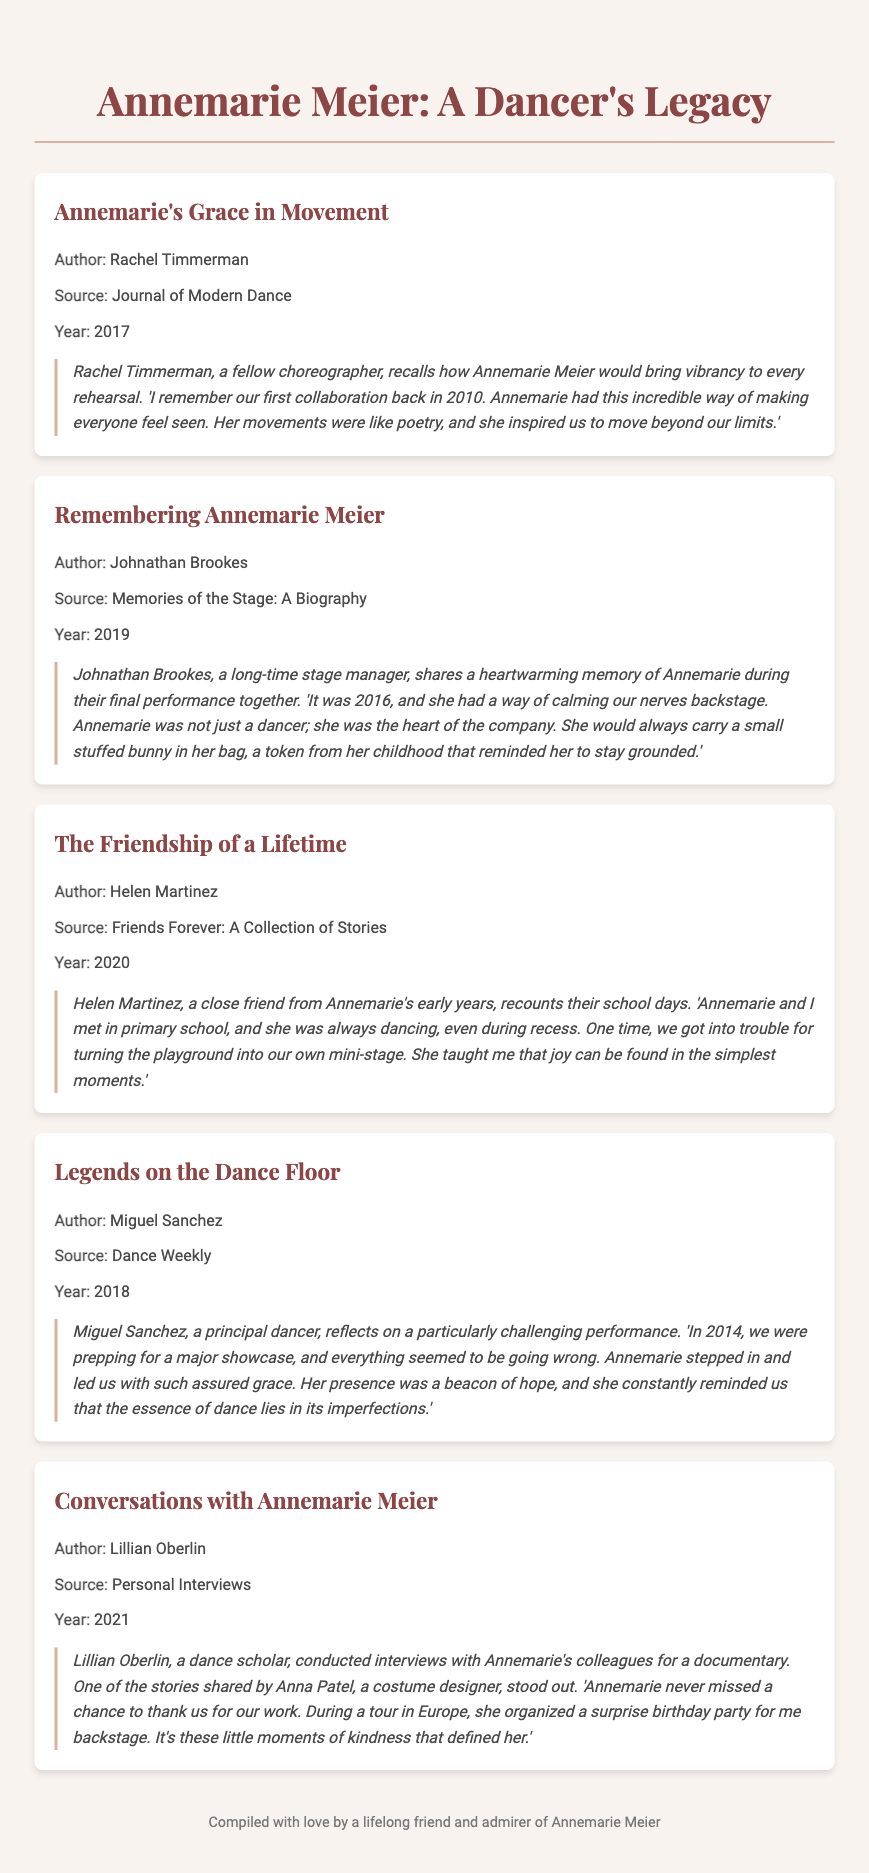What is the title of the first entry? The title of the first entry is provided in the document as the name of the section under the bibliography item.
Answer: Annemarie's Grace in Movement Who authored "Remembering Annemarie Meier"? The author of this particular bibliography item is stated clearly under the title as the name associated with it.
Answer: Johnathan Brookes In which year was "Legends on the Dance Floor" published? The year of publication is mentioned in the bibliography item's details.
Answer: 2018 What object did Annemarie carry for good luck? The document includes a specific anecdote that mentions an object Annemarie carried, which is identified within the text.
Answer: A small stuffed bunny How did Helen Martinez describe Annemarie during their school days? The description is found in the anecdote shared by Helen Martinez, highlighting Annemarie's behavior during recess.
Answer: Always dancing What theme is common across the anecdotes about Annemarie? The central theme can be inferred from the various shared memories and their emotional tone, which relates to how she impacted others.
Answer: Kindness What type of source is "Conversations with Annemarie Meier"? The source type is specified in the bibliographic entry.
Answer: Personal Interviews How did Annemarie's colleagues feel about her? The collective feelings of Annemarie's colleagues can be discerned through their anecdotes in the document, which provide a sense of their respect and admiration.
Answer: Inspired 